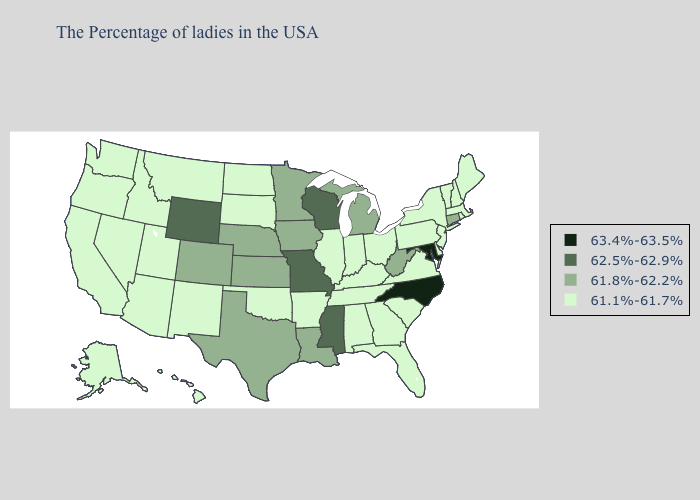What is the value of Illinois?
Keep it brief. 61.1%-61.7%. What is the highest value in states that border Massachusetts?
Answer briefly. 61.8%-62.2%. Does North Carolina have the lowest value in the South?
Keep it brief. No. What is the lowest value in states that border Colorado?
Answer briefly. 61.1%-61.7%. Among the states that border Idaho , which have the lowest value?
Answer briefly. Utah, Montana, Nevada, Washington, Oregon. What is the lowest value in the USA?
Give a very brief answer. 61.1%-61.7%. What is the value of South Carolina?
Be succinct. 61.1%-61.7%. Is the legend a continuous bar?
Short answer required. No. Name the states that have a value in the range 62.5%-62.9%?
Write a very short answer. Wisconsin, Mississippi, Missouri, Wyoming. What is the highest value in the USA?
Give a very brief answer. 63.4%-63.5%. Name the states that have a value in the range 62.5%-62.9%?
Answer briefly. Wisconsin, Mississippi, Missouri, Wyoming. What is the highest value in the USA?
Concise answer only. 63.4%-63.5%. What is the value of North Dakota?
Be succinct. 61.1%-61.7%. What is the value of Wyoming?
Answer briefly. 62.5%-62.9%. Name the states that have a value in the range 61.8%-62.2%?
Short answer required. Connecticut, West Virginia, Michigan, Louisiana, Minnesota, Iowa, Kansas, Nebraska, Texas, Colorado. 